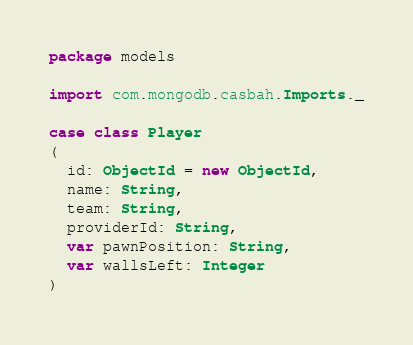Convert code to text. <code><loc_0><loc_0><loc_500><loc_500><_Scala_>package models

import com.mongodb.casbah.Imports._

case class Player
(
  id: ObjectId = new ObjectId,
  name: String,
  team: String,
  providerId: String,
  var pawnPosition: String,
  var wallsLeft: Integer
)</code> 